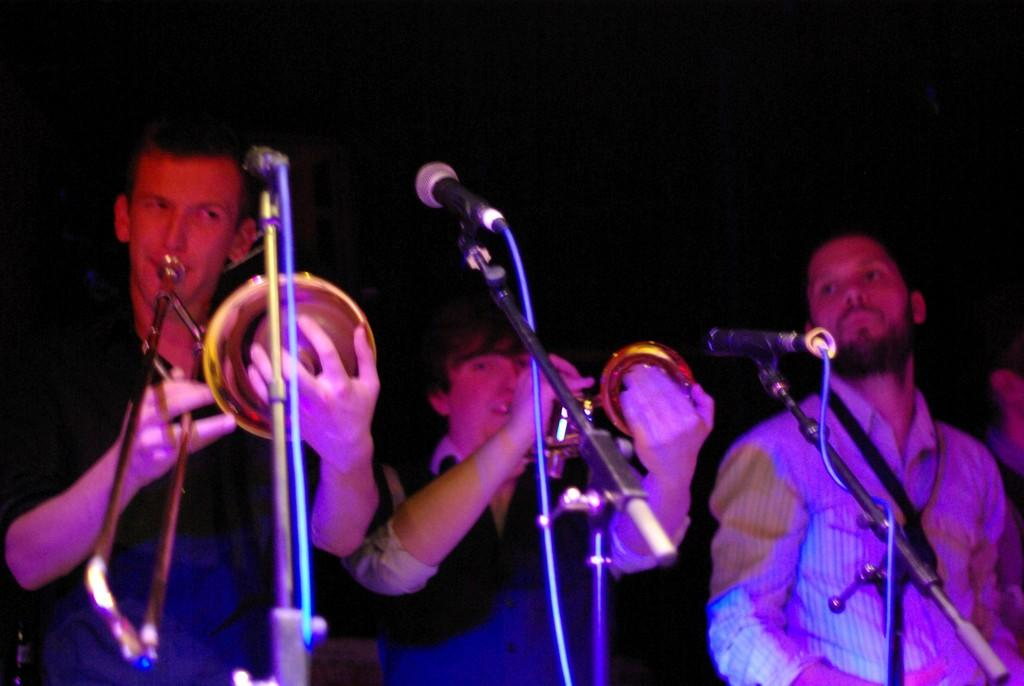What are the two persons in the image doing? The two persons in the image are playing saxophones. Where are the two persons standing in relation to the microphone? They are standing in front of a microphone. Can you describe the man on the right side of the image? The man on the right side of the image is also standing in front of a microphone. What type of glove is the man on the right side of the image wearing? There is no glove visible on the man on the right side of the image. What is the man on the right side of the image using to bake a cake? There is no cake or baking equipment present in the image. 